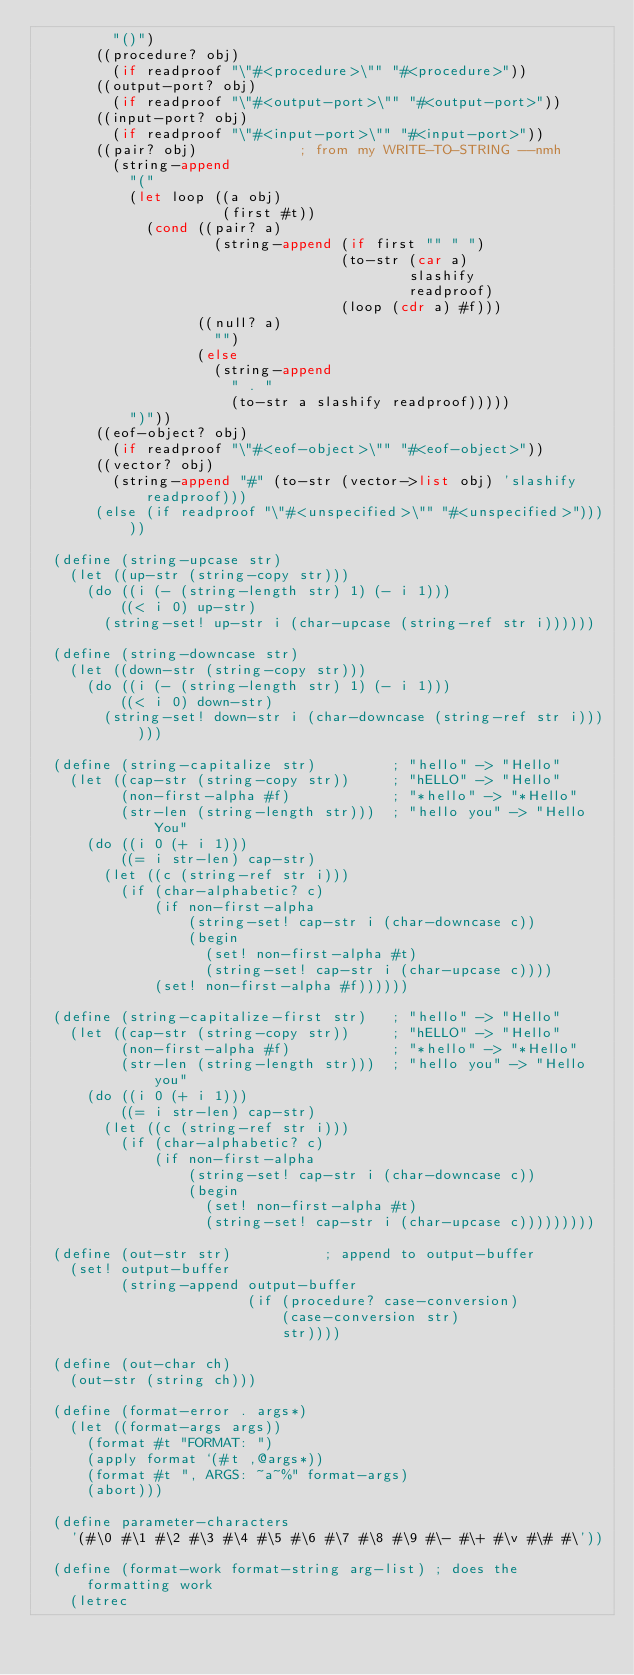<code> <loc_0><loc_0><loc_500><loc_500><_Scheme_>         "()")
       ((procedure? obj)
         (if readproof "\"#<procedure>\"" "#<procedure>"))
       ((output-port? obj)
         (if readproof "\"#<output-port>\"" "#<output-port>"))
       ((input-port? obj)
         (if readproof "\"#<input-port>\"" "#<input-port>"))
       ((pair? obj)            ; from my WRITE-TO-STRING --nmh
         (string-append
           "("
           (let loop ((a obj)
                      (first #t))
             (cond ((pair? a)
                     (string-append (if first "" " ")
                                    (to-str (car a)
                                            slashify
                                            readproof)
                                    (loop (cdr a) #f)))
                   ((null? a)
                     "")
                   (else
                     (string-append
                       " . "
                       (to-str a slashify readproof)))))
           ")"))
       ((eof-object? obj)
         (if readproof "\"#<eof-object>\"" "#<eof-object>"))
       ((vector? obj)
         (string-append "#" (to-str (vector->list obj) 'slashify readproof)))
       (else (if readproof "\"#<unspecified>\"" "#<unspecified>")))))

  (define (string-upcase str)
    (let ((up-str (string-copy str)))
      (do ((i (- (string-length str) 1) (- i 1)))
          ((< i 0) up-str)
        (string-set! up-str i (char-upcase (string-ref str i))))))

  (define (string-downcase str)
    (let ((down-str (string-copy str)))
      (do ((i (- (string-length str) 1) (- i 1)))
          ((< i 0) down-str)
        (string-set! down-str i (char-downcase (string-ref str i))))))

  (define (string-capitalize str)         ; "hello" -> "Hello"
    (let ((cap-str (string-copy str))     ; "hELLO" -> "Hello"
          (non-first-alpha #f)            ; "*hello" -> "*Hello"
          (str-len (string-length str)))  ; "hello you" -> "Hello You"
      (do ((i 0 (+ i 1)))
          ((= i str-len) cap-str)
        (let ((c (string-ref str i)))
          (if (char-alphabetic? c)
              (if non-first-alpha
                  (string-set! cap-str i (char-downcase c))
                  (begin
                    (set! non-first-alpha #t)
                    (string-set! cap-str i (char-upcase c))))
              (set! non-first-alpha #f))))))

  (define (string-capitalize-first str)   ; "hello" -> "Hello"
    (let ((cap-str (string-copy str))     ; "hELLO" -> "Hello"
          (non-first-alpha #f)            ; "*hello" -> "*Hello"
          (str-len (string-length str)))  ; "hello you" -> "Hello you"
      (do ((i 0 (+ i 1)))
          ((= i str-len) cap-str)
        (let ((c (string-ref str i)))
          (if (char-alphabetic? c)
              (if non-first-alpha
                  (string-set! cap-str i (char-downcase c))
                  (begin
                    (set! non-first-alpha #t)
                    (string-set! cap-str i (char-upcase c)))))))))

  (define (out-str str)           ; append to output-buffer
    (set! output-buffer
          (string-append output-buffer
                         (if (procedure? case-conversion)
                             (case-conversion str)
                             str))))

  (define (out-char ch)
    (out-str (string ch)))

  (define (format-error . args*)
    (let ((format-args args))
      (format #t "FORMAT: ")
      (apply format `(#t ,@args*))
      (format #t ", ARGS: ~a~%" format-args)
      (abort)))

  (define parameter-characters
    '(#\0 #\1 #\2 #\3 #\4 #\5 #\6 #\7 #\8 #\9 #\- #\+ #\v #\# #\'))

  (define (format-work format-string arg-list) ; does the formatting work
    (letrec</code> 